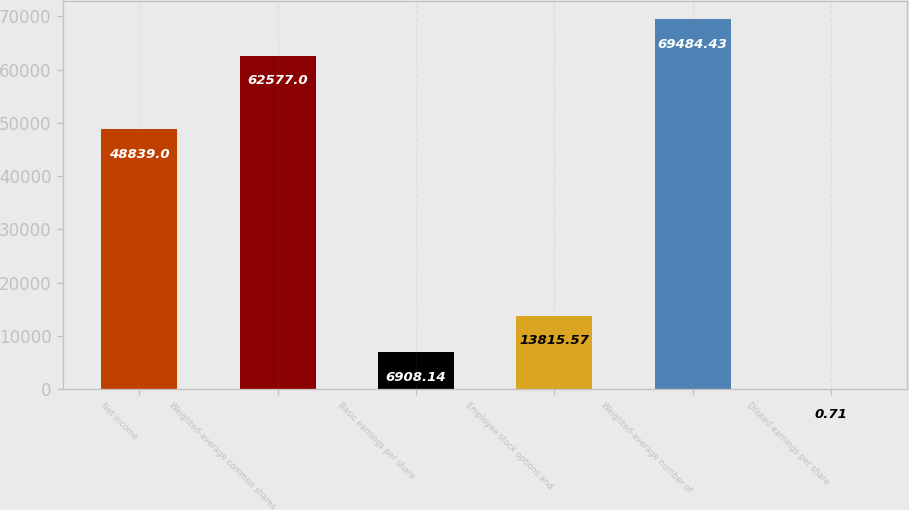Convert chart to OTSL. <chart><loc_0><loc_0><loc_500><loc_500><bar_chart><fcel>Net income<fcel>Weighted-average common shares<fcel>Basic earnings per share<fcel>Employee stock options and<fcel>Weighted-average number of<fcel>Diluted earnings per share<nl><fcel>48839<fcel>62577<fcel>6908.14<fcel>13815.6<fcel>69484.4<fcel>0.71<nl></chart> 